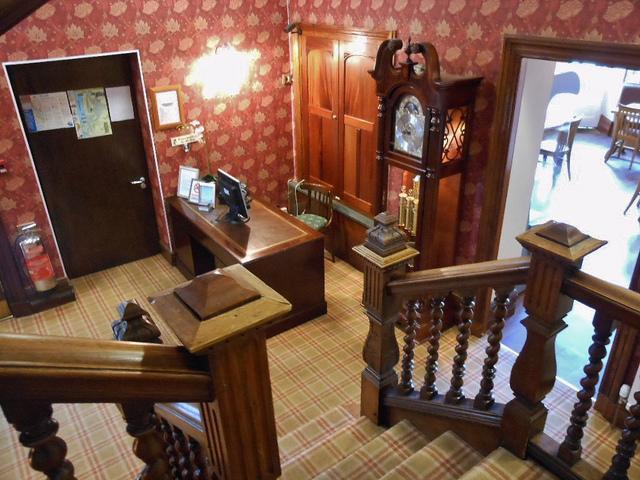What is attached to the brown door?
Indicate the correct response and explain using: 'Answer: answer
Rationale: rationale.'
Options: Garbage bag, pastries, cross, papers. Answer: papers.
Rationale: Papers are sticked to the brown door 